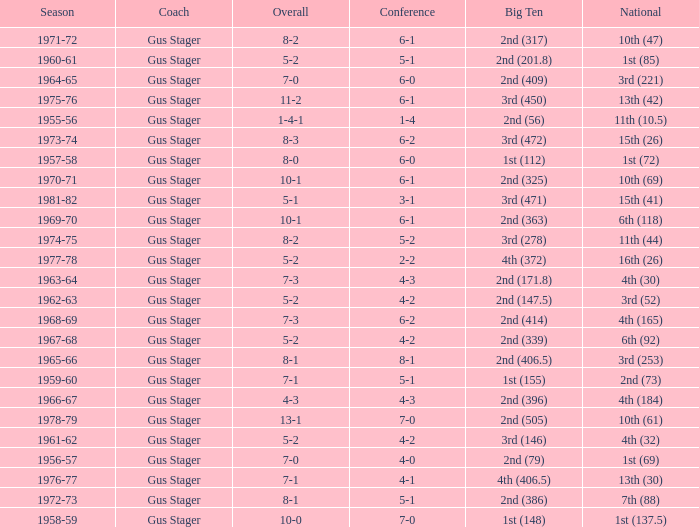What is the Coach with a Big Ten that is 3rd (278)? Gus Stager. 